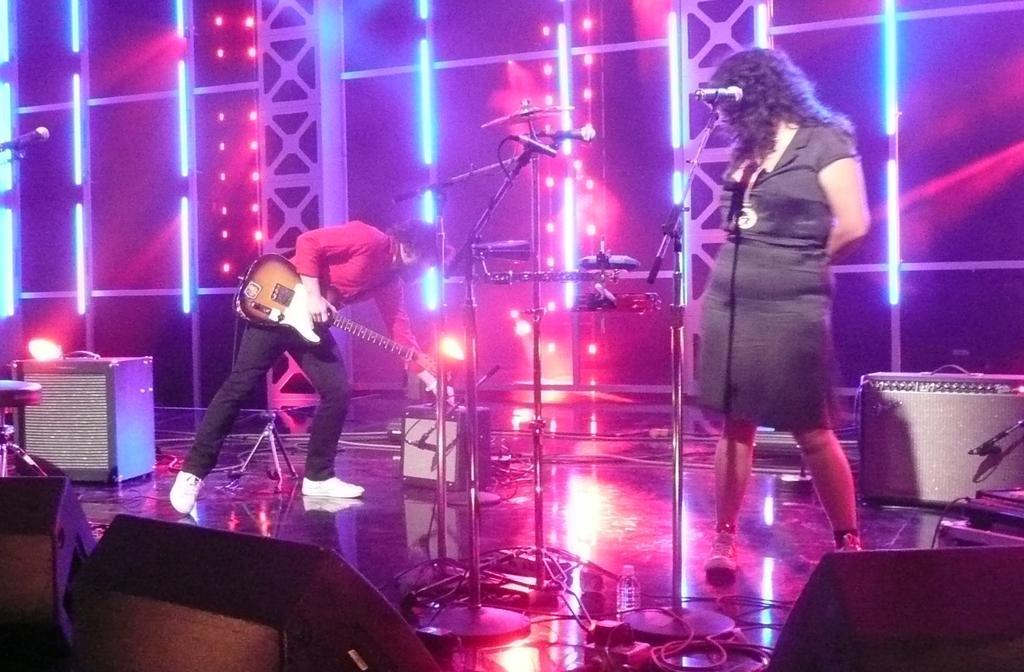How would you summarize this image in a sentence or two? In the middle of the image two persons standing and there are some microphones and musical instruments. Behind them there are some lights and there are some electronic devices. Bottom of the image there are some lights. 